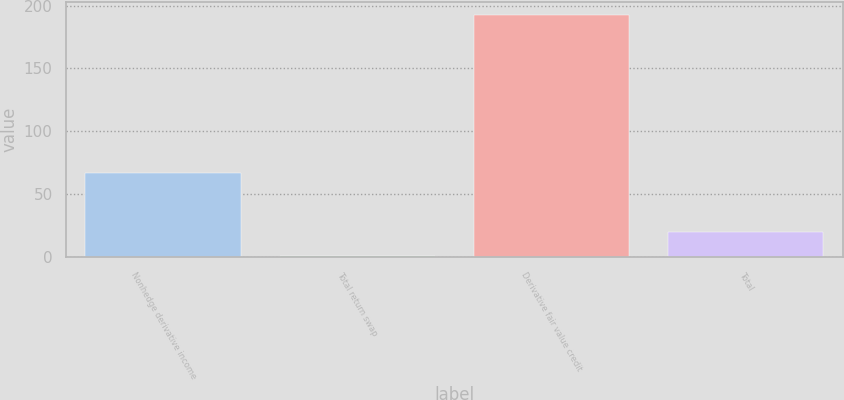Convert chart to OTSL. <chart><loc_0><loc_0><loc_500><loc_500><bar_chart><fcel>Nonhedge derivative income<fcel>Total return swap<fcel>Derivative fair value credit<fcel>Total<nl><fcel>66.7<fcel>0.5<fcel>192.9<fcel>19.74<nl></chart> 